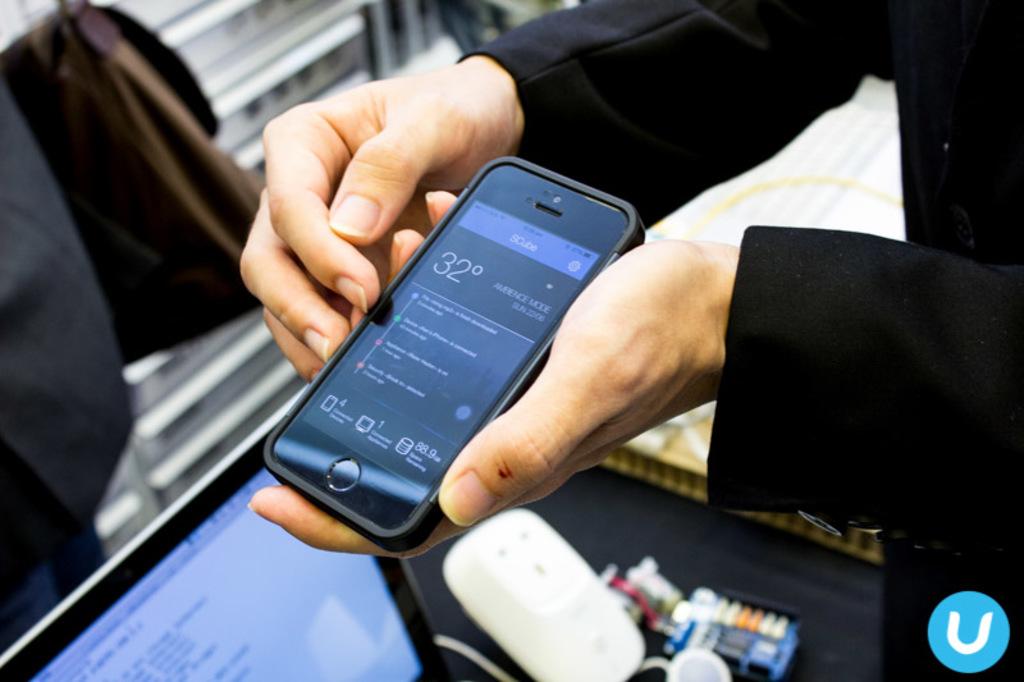What temperature in celcius does the phone show?
Provide a short and direct response. 32. What letter logo can be seen in the bottom right?
Provide a short and direct response. U. 